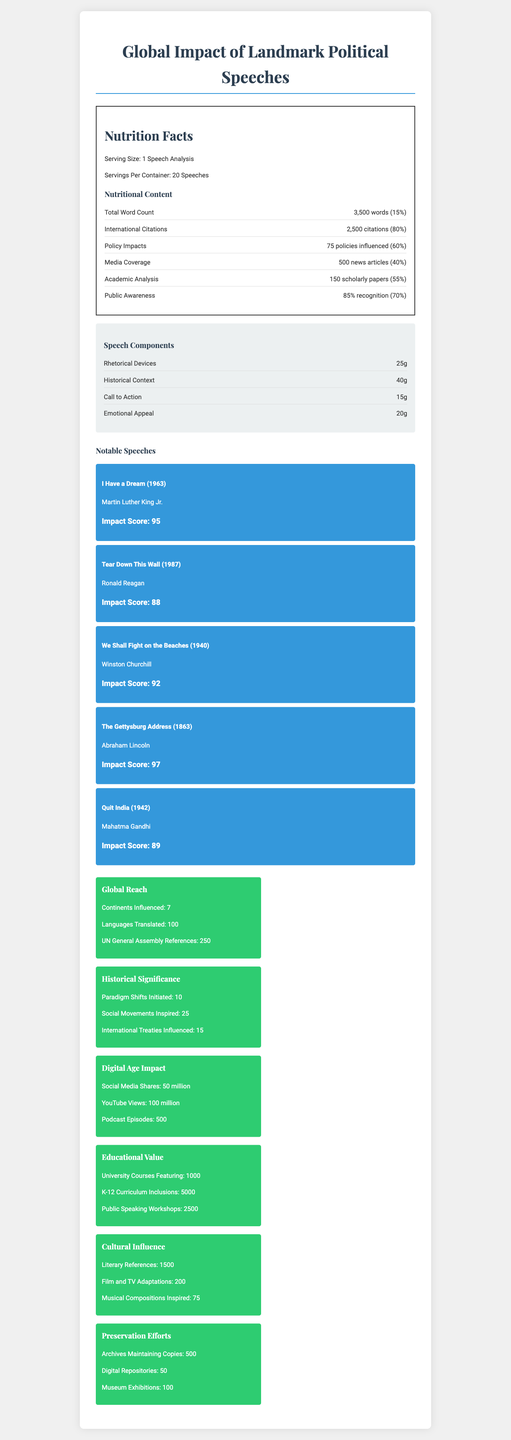what is the serving size of the document? The serving size is stated directly in the nutrition label under "Serving Size: 1 Speech Analysis".
Answer: 1 Speech Analysis how many citations are listed for the speeches? The number of international citations is given as "2,500 citations" in the Nutrition Content section under "International Citations".
Answer: 2,500 citations how many notable speeches are included in the document? The Notable Speeches section lists 5 speeches with titles, speakers, years, and impact scores.
Answer: 5 which speech has the highest impact score? A. I Have a Dream B. Tear Down This Wall C. The Gettysburg Address D. Quit India The Gettysburg Address by Abraham Lincoln has the highest impact score of 97.
Answer: C how is the media coverage of the speeches quantified in the document? The media coverage is quantified as "500 news articles" in the Nutrition Content section under "Media Coverage".
Answer: 500 news articles what percentage of public awareness is reported? The public awareness is reported as "85% recognition" in the Nutrition Content section under "Public Awareness".
Answer: 85% how many continents have been influenced by these speeches? The Global Reach section mentions "Continents Influenced: 7".
Answer: 7 which historical speech component is the most heavily weighted in the analysis? The Speech Components section lists "Historical Context: 40g" as the most heavily weighted component.
Answer: Historical Context: 40g how many social movements have been inspired by these speeches? The Historical Significance section mentions "Social Movements Inspired: 25".
Answer: 25 what is the impact score of Ronald Reagan's "Tear Down This Wall" speech? The notables speeches section shows "Tear Down This Wall" with an impact score of 88.
Answer: 88 how many international treaties have been influenced by these landmark speeches? The Historical Significance section reports "International Treaties Influenced: 15".
Answer: 15 what is the amount of rhetorical devices used per speech analysis? The Speech Components section lists the amount of rhetorical devices as "25g".
Answer: 25g what overarching theme does the document cover? The title and content of the document cover the global influence of important political speeches throughout history.
Answer: Global impact of landmark political speeches how many scholarly papers analyze the speeches? The number of scholarly papers is given as "150 scholarly papers" in the Nutrition Content section under "Academic Analysis".
Answer: 150 scholarly papers what does the document suggest about the educational value of these speeches? A. Limited to university courses B. High inclusion in K-12 curriculum C. Only a few public speaking workshops D. Not included in educational contexts The document shows wide educational inclusion with "University Courses Featuring: 1000", "K-12 Curriculum Inclusions: 5000", and "Public Speaking Workshops: 2500".
Answer: B does the document provide the exact year of each notable speech? Each notable speech listed in the document includes the exact year it was delivered (e.g., Martin Luther King Jr.'s "I Have a Dream" in 1963).
Answer: Yes does the document quantificate the social media shares of the speeches? The Digital Age Impact section mentions "Social Media Shares: 50 million".
Answer: Yes how have the speeches been preserved according to the document? The Preservation Efforts section mentions "Archives Maintaining Copies: 500", "Digital Repositories: 50", and "Museum Exhibitions: 100".
Answer: Through archives, digital repositories, and museum exhibitions which notable speech inspired the most policies based on the document? The document does not specify which speeches inspired which or how many policies.
Answer: Cannot be determined 